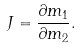<formula> <loc_0><loc_0><loc_500><loc_500>J = \frac { \partial m _ { 1 } } { \partial m _ { 2 } } .</formula> 